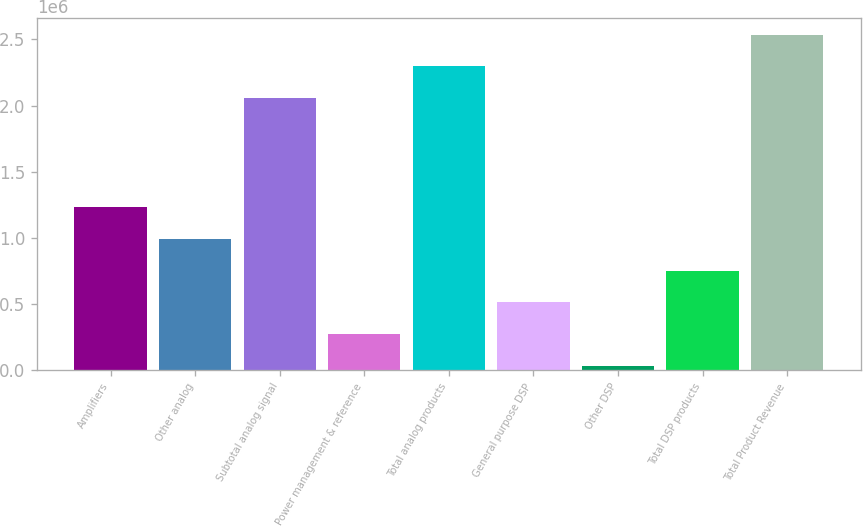<chart> <loc_0><loc_0><loc_500><loc_500><bar_chart><fcel>Amplifiers<fcel>Other analog<fcel>Subtotal analog signal<fcel>Power management & reference<fcel>Total analog products<fcel>General purpose DSP<fcel>Other DSP<fcel>Total DSP products<fcel>Total Product Revenue<nl><fcel>1.23158e+06<fcel>991946<fcel>2.05785e+06<fcel>273059<fcel>2.29748e+06<fcel>512688<fcel>33430<fcel>752317<fcel>2.53711e+06<nl></chart> 